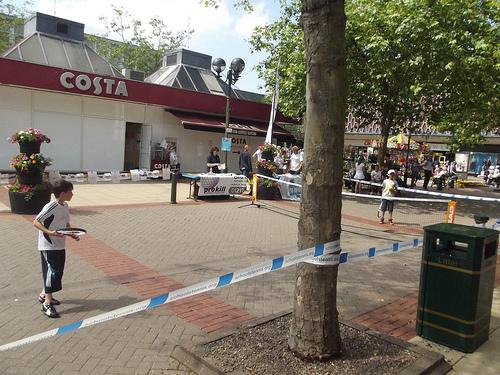Question: what is the color of the bark on the tree?
Choices:
A. Gray.
B. Red-Orange.
C. Brown.
D. Green.
Answer with the letter. Answer: C Question: what material is the surface the boy is standing on?
Choices:
A. Concrete.
B. Asphalt.
C. Brick.
D. Gravel.
Answer with the letter. Answer: C Question: where was this image taken?
Choices:
A. In the alley.
B. Downtown.
C. By the corner store.
D. On the street.
Answer with the letter. Answer: D 